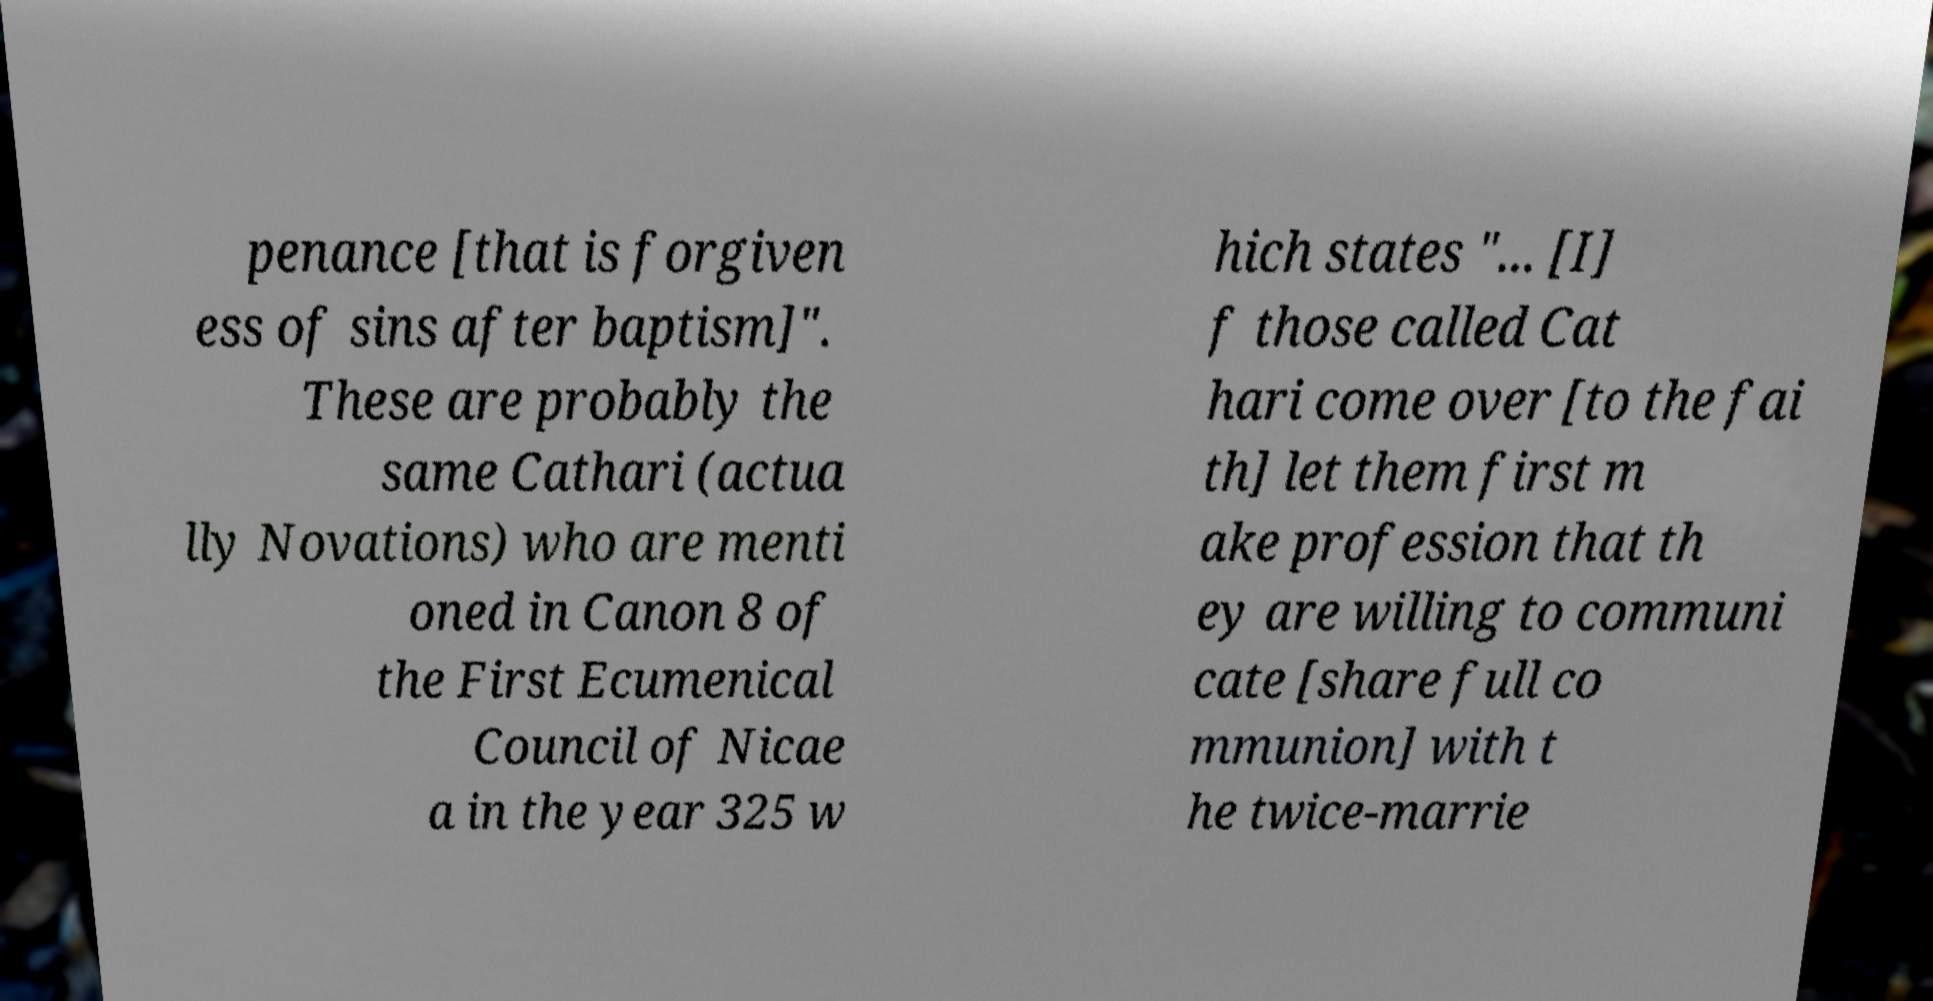Please read and relay the text visible in this image. What does it say? penance [that is forgiven ess of sins after baptism]". These are probably the same Cathari (actua lly Novations) who are menti oned in Canon 8 of the First Ecumenical Council of Nicae a in the year 325 w hich states "... [I] f those called Cat hari come over [to the fai th] let them first m ake profession that th ey are willing to communi cate [share full co mmunion] with t he twice-marrie 